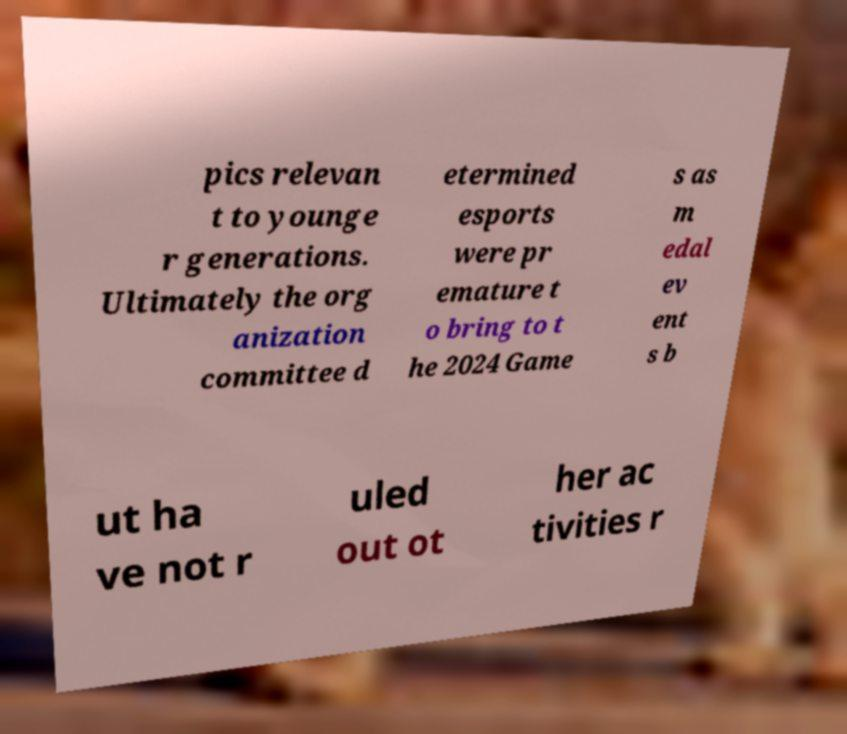Could you extract and type out the text from this image? pics relevan t to younge r generations. Ultimately the org anization committee d etermined esports were pr emature t o bring to t he 2024 Game s as m edal ev ent s b ut ha ve not r uled out ot her ac tivities r 